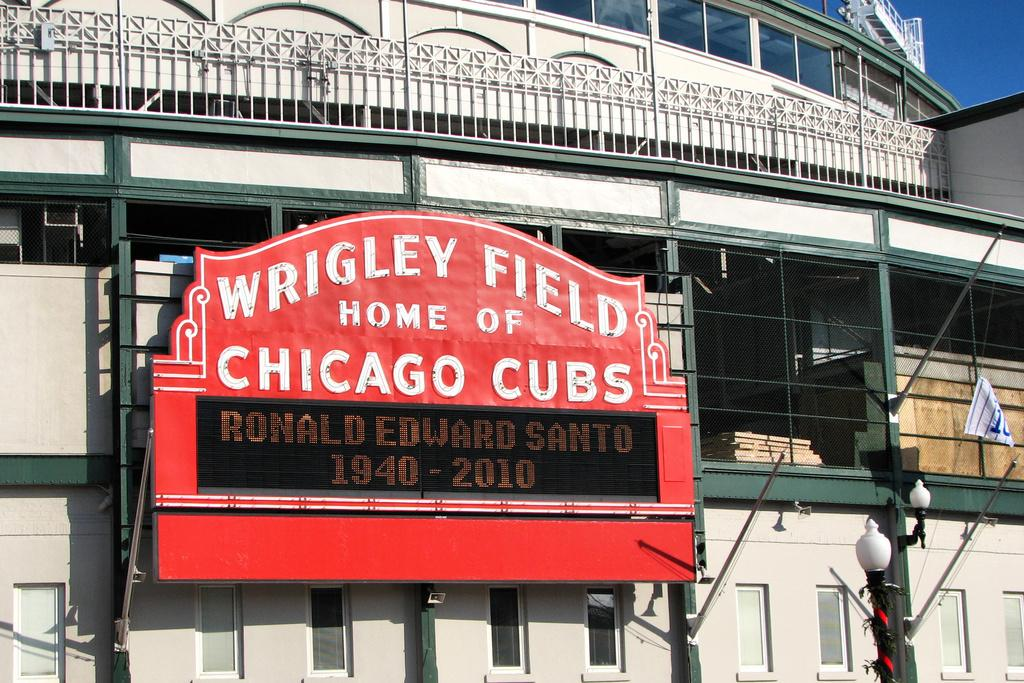What is located in the center of the image? There is a board on a building in the center of the image. What can be seen in the background of the image? There are buildings and the sky visible in the background. Where are the lights located in the image? The lights are in the bottom right corner of the image. What type of drink is the boy holding in the image? There is no boy or drink present in the image. 